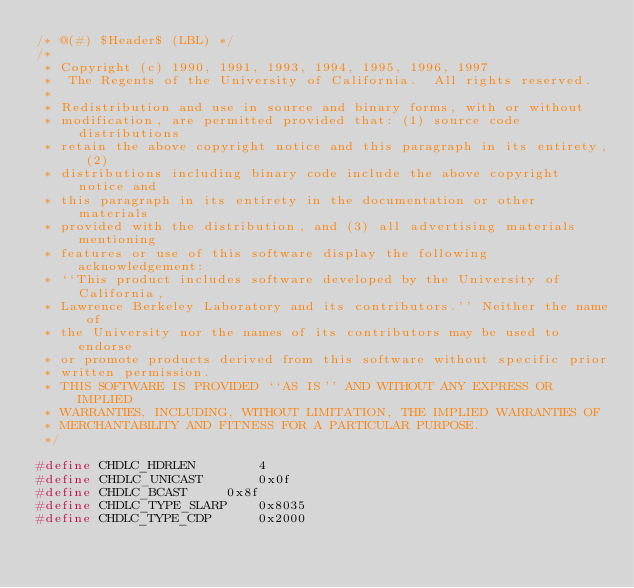<code> <loc_0><loc_0><loc_500><loc_500><_C_>/* @(#) $Header$ (LBL) */
/*
 * Copyright (c) 1990, 1991, 1993, 1994, 1995, 1996, 1997
 *	The Regents of the University of California.  All rights reserved.
 *
 * Redistribution and use in source and binary forms, with or without
 * modification, are permitted provided that: (1) source code distributions
 * retain the above copyright notice and this paragraph in its entirety, (2)
 * distributions including binary code include the above copyright notice and
 * this paragraph in its entirety in the documentation or other materials
 * provided with the distribution, and (3) all advertising materials mentioning
 * features or use of this software display the following acknowledgement:
 * ``This product includes software developed by the University of California,
 * Lawrence Berkeley Laboratory and its contributors.'' Neither the name of
 * the University nor the names of its contributors may be used to endorse
 * or promote products derived from this software without specific prior
 * written permission.
 * THIS SOFTWARE IS PROVIDED ``AS IS'' AND WITHOUT ANY EXPRESS OR IMPLIED
 * WARRANTIES, INCLUDING, WITHOUT LIMITATION, THE IMPLIED WARRANTIES OF
 * MERCHANTABILITY AND FITNESS FOR A PARTICULAR PURPOSE.
 */

#define CHDLC_HDRLEN 		4
#define CHDLC_UNICAST		0x0f
#define CHDLC_BCAST		0x8f
#define CHDLC_TYPE_SLARP	0x8035
#define CHDLC_TYPE_CDP		0x2000
</code> 